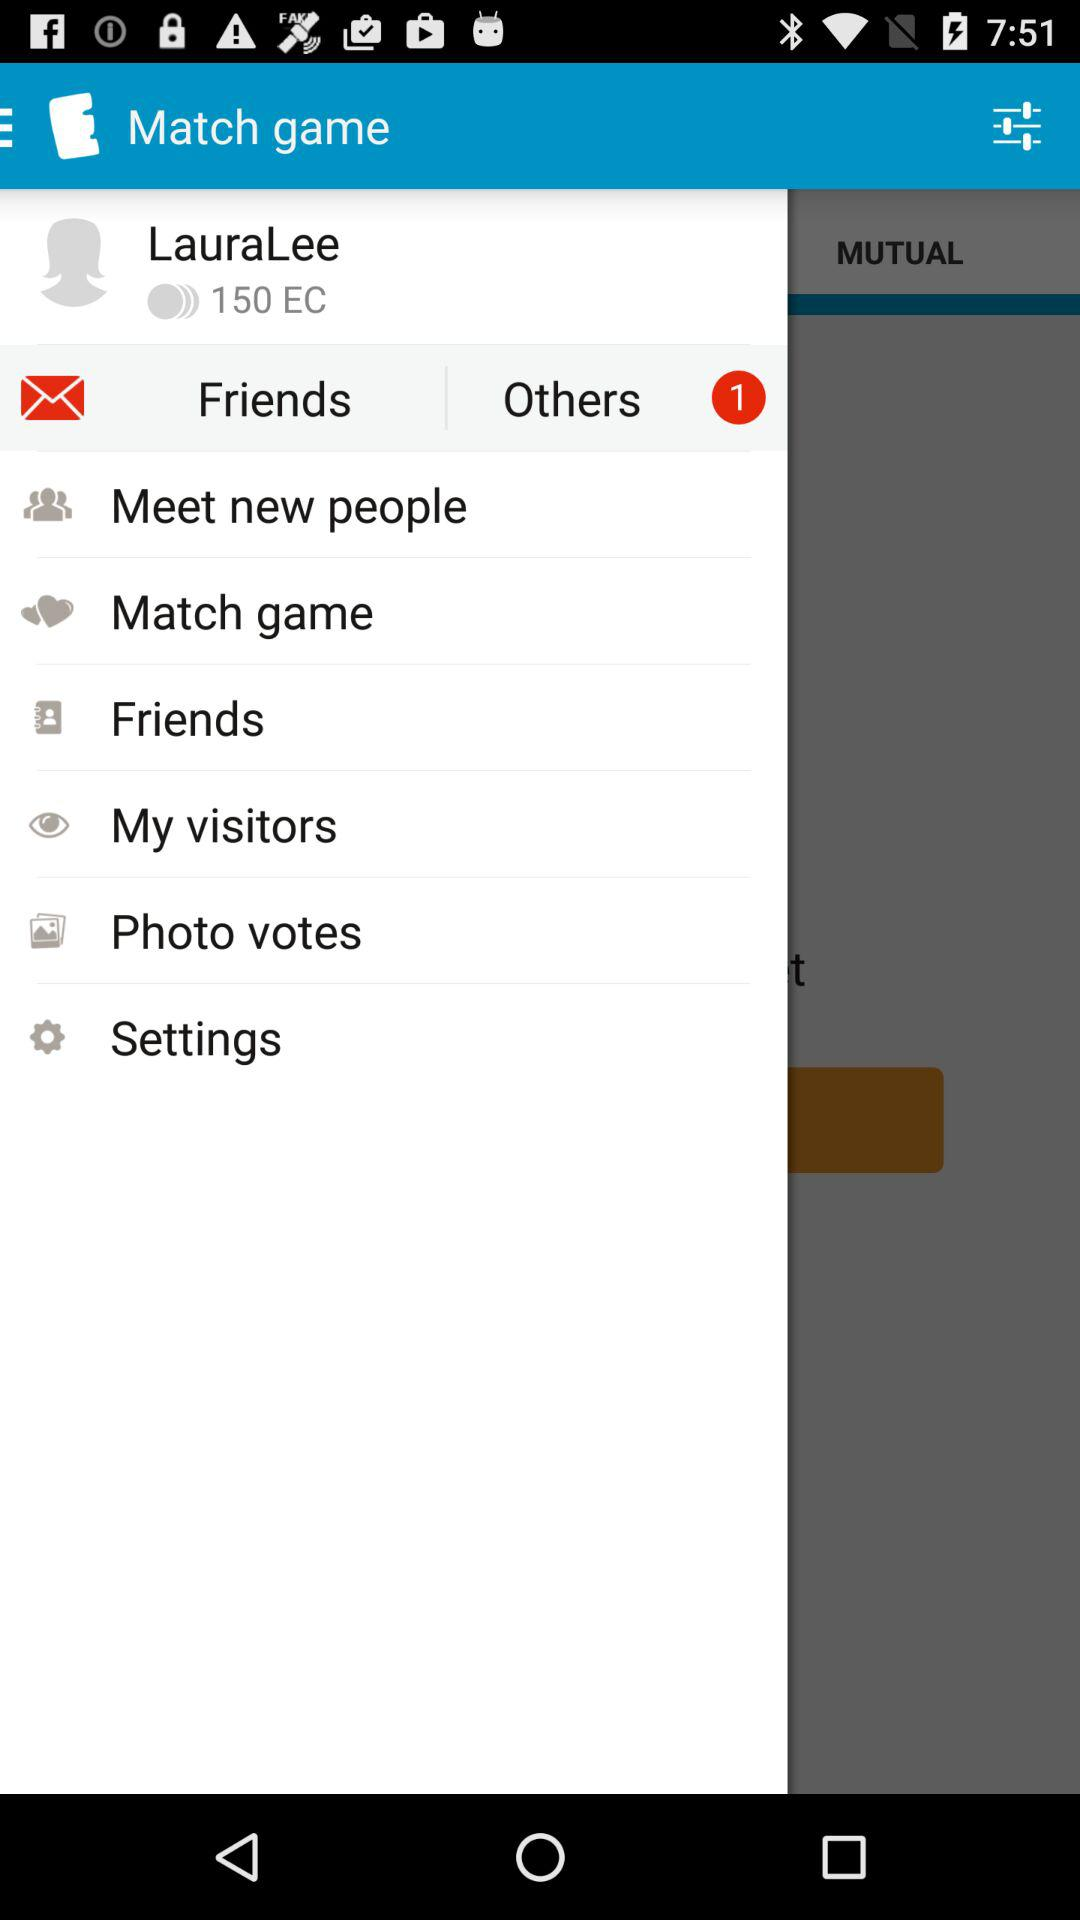What is the application name? The application name is "Match game". 